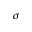<formula> <loc_0><loc_0><loc_500><loc_500>\sigma</formula> 